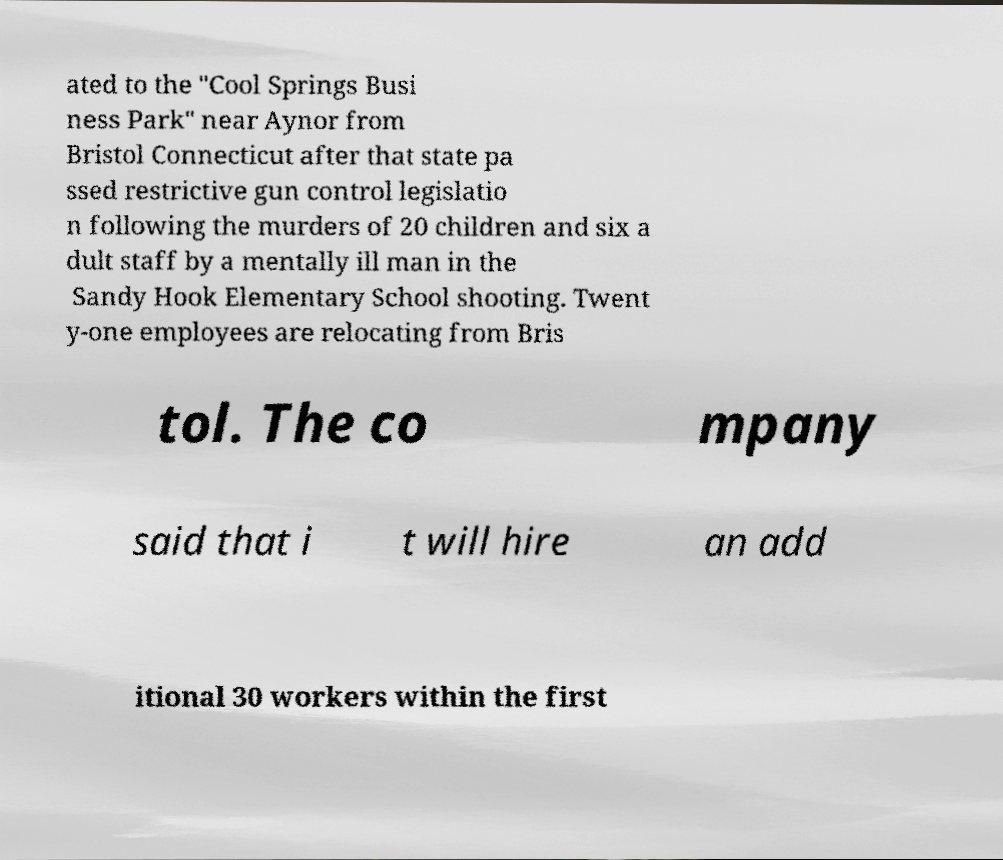Could you extract and type out the text from this image? ated to the "Cool Springs Busi ness Park" near Aynor from Bristol Connecticut after that state pa ssed restrictive gun control legislatio n following the murders of 20 children and six a dult staff by a mentally ill man in the Sandy Hook Elementary School shooting. Twent y-one employees are relocating from Bris tol. The co mpany said that i t will hire an add itional 30 workers within the first 